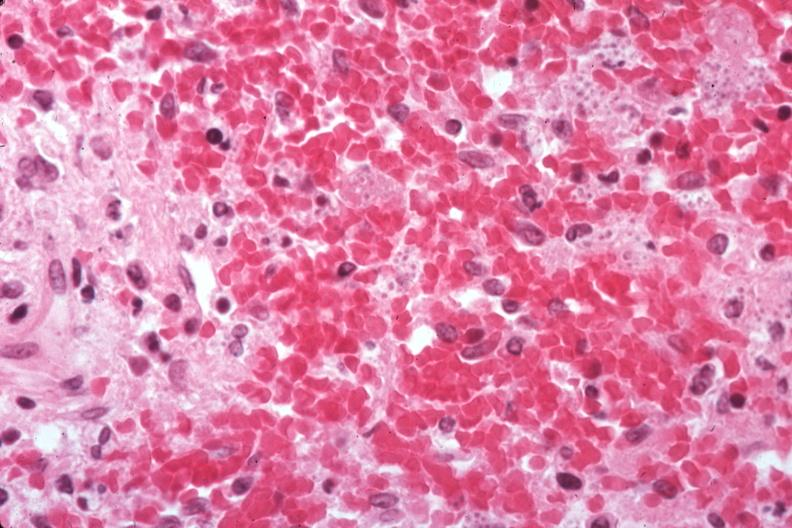what easily seen?
Answer the question using a single word or phrase. Organisms 